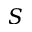<formula> <loc_0><loc_0><loc_500><loc_500>S</formula> 